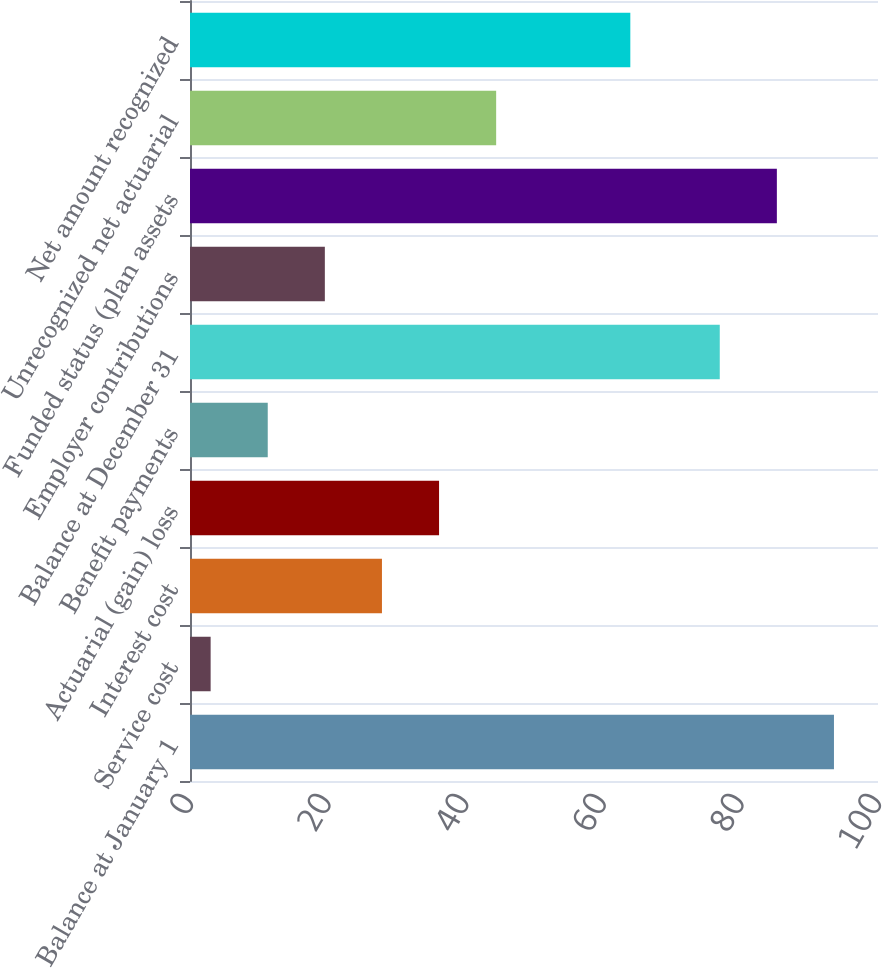Convert chart. <chart><loc_0><loc_0><loc_500><loc_500><bar_chart><fcel>Balance at January 1<fcel>Service cost<fcel>Interest cost<fcel>Actuarial (gain) loss<fcel>Benefit payments<fcel>Balance at December 31<fcel>Employer contributions<fcel>Funded status (plan assets<fcel>Unrecognized net actuarial<fcel>Net amount recognized<nl><fcel>93.6<fcel>3<fcel>27.9<fcel>36.2<fcel>11.3<fcel>77<fcel>19.6<fcel>85.3<fcel>44.5<fcel>64<nl></chart> 